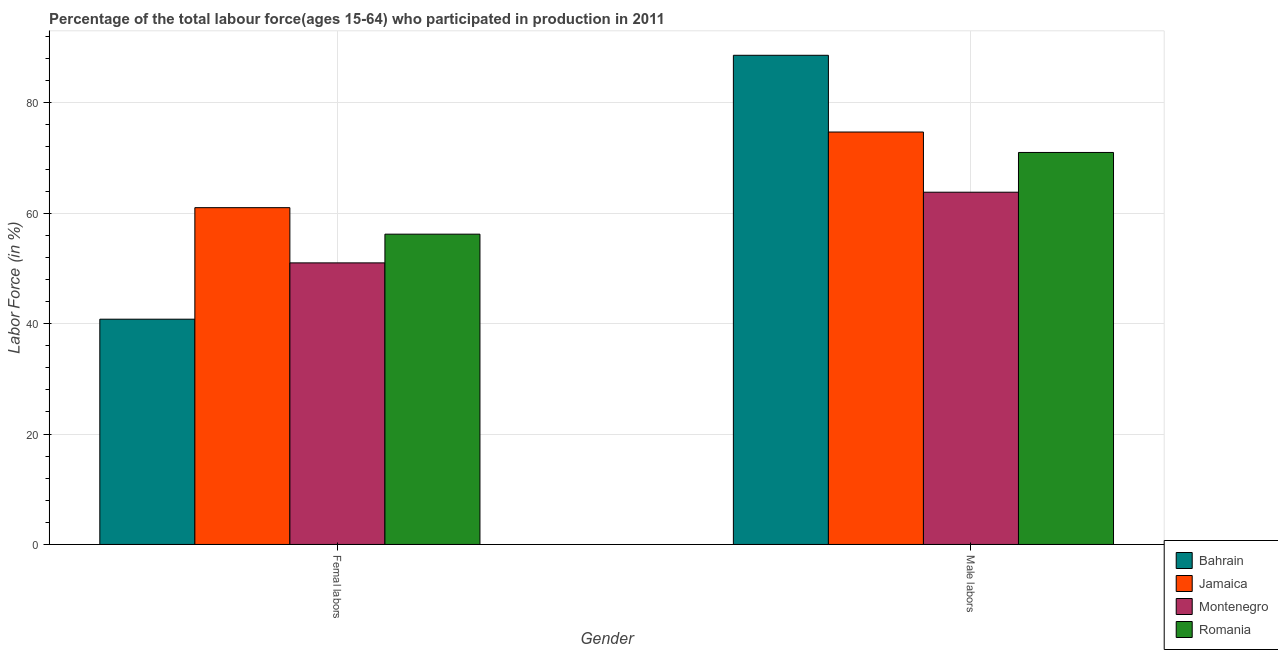How many different coloured bars are there?
Provide a succinct answer. 4. How many groups of bars are there?
Ensure brevity in your answer.  2. What is the label of the 1st group of bars from the left?
Provide a short and direct response. Femal labors. What is the percentage of male labour force in Montenegro?
Give a very brief answer. 63.8. Across all countries, what is the maximum percentage of male labour force?
Your answer should be very brief. 88.6. Across all countries, what is the minimum percentage of male labour force?
Your answer should be compact. 63.8. In which country was the percentage of female labor force maximum?
Ensure brevity in your answer.  Jamaica. In which country was the percentage of male labour force minimum?
Offer a terse response. Montenegro. What is the total percentage of female labor force in the graph?
Make the answer very short. 209. What is the difference between the percentage of male labour force in Montenegro and that in Bahrain?
Offer a terse response. -24.8. What is the average percentage of female labor force per country?
Make the answer very short. 52.25. What is the difference between the percentage of female labor force and percentage of male labour force in Romania?
Offer a very short reply. -14.8. In how many countries, is the percentage of female labor force greater than 88 %?
Offer a terse response. 0. What is the ratio of the percentage of female labor force in Romania to that in Jamaica?
Offer a terse response. 0.92. In how many countries, is the percentage of female labor force greater than the average percentage of female labor force taken over all countries?
Make the answer very short. 2. What does the 3rd bar from the left in Femal labors represents?
Your response must be concise. Montenegro. What does the 2nd bar from the right in Male labors represents?
Make the answer very short. Montenegro. Does the graph contain grids?
Provide a succinct answer. Yes. How many legend labels are there?
Provide a short and direct response. 4. How are the legend labels stacked?
Your answer should be compact. Vertical. What is the title of the graph?
Your answer should be compact. Percentage of the total labour force(ages 15-64) who participated in production in 2011. What is the label or title of the X-axis?
Your answer should be very brief. Gender. What is the Labor Force (in %) of Bahrain in Femal labors?
Ensure brevity in your answer.  40.8. What is the Labor Force (in %) of Jamaica in Femal labors?
Offer a very short reply. 61. What is the Labor Force (in %) of Romania in Femal labors?
Offer a terse response. 56.2. What is the Labor Force (in %) of Bahrain in Male labors?
Keep it short and to the point. 88.6. What is the Labor Force (in %) in Jamaica in Male labors?
Provide a short and direct response. 74.7. What is the Labor Force (in %) of Montenegro in Male labors?
Your answer should be very brief. 63.8. What is the Labor Force (in %) of Romania in Male labors?
Ensure brevity in your answer.  71. Across all Gender, what is the maximum Labor Force (in %) in Bahrain?
Your answer should be very brief. 88.6. Across all Gender, what is the maximum Labor Force (in %) of Jamaica?
Provide a short and direct response. 74.7. Across all Gender, what is the maximum Labor Force (in %) in Montenegro?
Your answer should be very brief. 63.8. Across all Gender, what is the minimum Labor Force (in %) of Bahrain?
Your response must be concise. 40.8. Across all Gender, what is the minimum Labor Force (in %) in Jamaica?
Keep it short and to the point. 61. Across all Gender, what is the minimum Labor Force (in %) in Romania?
Provide a short and direct response. 56.2. What is the total Labor Force (in %) of Bahrain in the graph?
Keep it short and to the point. 129.4. What is the total Labor Force (in %) of Jamaica in the graph?
Your answer should be compact. 135.7. What is the total Labor Force (in %) in Montenegro in the graph?
Make the answer very short. 114.8. What is the total Labor Force (in %) in Romania in the graph?
Offer a terse response. 127.2. What is the difference between the Labor Force (in %) in Bahrain in Femal labors and that in Male labors?
Your answer should be compact. -47.8. What is the difference between the Labor Force (in %) of Jamaica in Femal labors and that in Male labors?
Your response must be concise. -13.7. What is the difference between the Labor Force (in %) in Romania in Femal labors and that in Male labors?
Give a very brief answer. -14.8. What is the difference between the Labor Force (in %) of Bahrain in Femal labors and the Labor Force (in %) of Jamaica in Male labors?
Provide a short and direct response. -33.9. What is the difference between the Labor Force (in %) of Bahrain in Femal labors and the Labor Force (in %) of Montenegro in Male labors?
Your answer should be very brief. -23. What is the difference between the Labor Force (in %) of Bahrain in Femal labors and the Labor Force (in %) of Romania in Male labors?
Your response must be concise. -30.2. What is the difference between the Labor Force (in %) in Jamaica in Femal labors and the Labor Force (in %) in Montenegro in Male labors?
Offer a very short reply. -2.8. What is the average Labor Force (in %) of Bahrain per Gender?
Provide a succinct answer. 64.7. What is the average Labor Force (in %) in Jamaica per Gender?
Keep it short and to the point. 67.85. What is the average Labor Force (in %) of Montenegro per Gender?
Your response must be concise. 57.4. What is the average Labor Force (in %) in Romania per Gender?
Your answer should be very brief. 63.6. What is the difference between the Labor Force (in %) of Bahrain and Labor Force (in %) of Jamaica in Femal labors?
Offer a very short reply. -20.2. What is the difference between the Labor Force (in %) of Bahrain and Labor Force (in %) of Romania in Femal labors?
Provide a short and direct response. -15.4. What is the difference between the Labor Force (in %) of Jamaica and Labor Force (in %) of Romania in Femal labors?
Your answer should be compact. 4.8. What is the difference between the Labor Force (in %) of Montenegro and Labor Force (in %) of Romania in Femal labors?
Your answer should be compact. -5.2. What is the difference between the Labor Force (in %) in Bahrain and Labor Force (in %) in Montenegro in Male labors?
Provide a short and direct response. 24.8. What is the difference between the Labor Force (in %) of Jamaica and Labor Force (in %) of Montenegro in Male labors?
Your answer should be very brief. 10.9. What is the difference between the Labor Force (in %) of Montenegro and Labor Force (in %) of Romania in Male labors?
Provide a short and direct response. -7.2. What is the ratio of the Labor Force (in %) of Bahrain in Femal labors to that in Male labors?
Offer a very short reply. 0.46. What is the ratio of the Labor Force (in %) in Jamaica in Femal labors to that in Male labors?
Keep it short and to the point. 0.82. What is the ratio of the Labor Force (in %) of Montenegro in Femal labors to that in Male labors?
Your answer should be compact. 0.8. What is the ratio of the Labor Force (in %) of Romania in Femal labors to that in Male labors?
Ensure brevity in your answer.  0.79. What is the difference between the highest and the second highest Labor Force (in %) in Bahrain?
Your answer should be compact. 47.8. What is the difference between the highest and the second highest Labor Force (in %) of Romania?
Your response must be concise. 14.8. What is the difference between the highest and the lowest Labor Force (in %) of Bahrain?
Your answer should be compact. 47.8. 